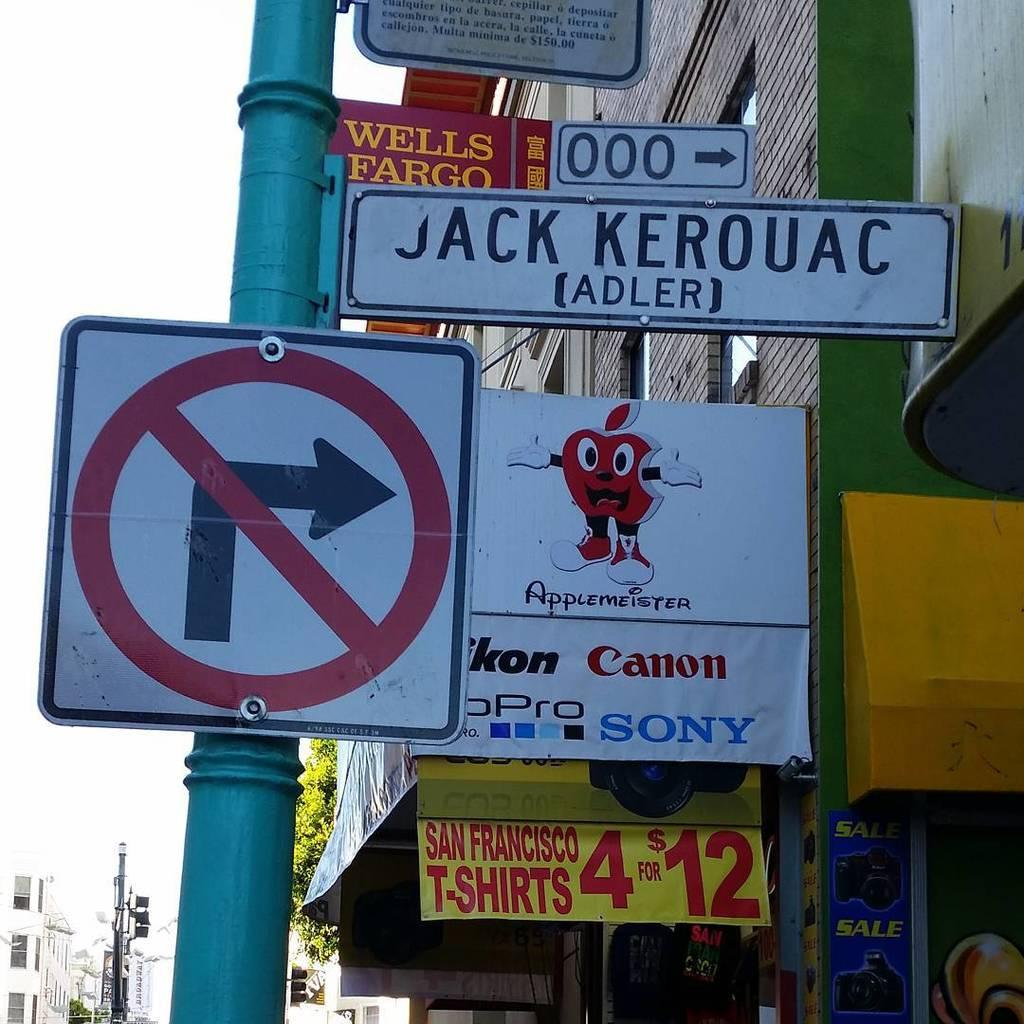<image>
Relay a brief, clear account of the picture shown. A not turn sign can be seen next to a sign with the Sony logo on it. 